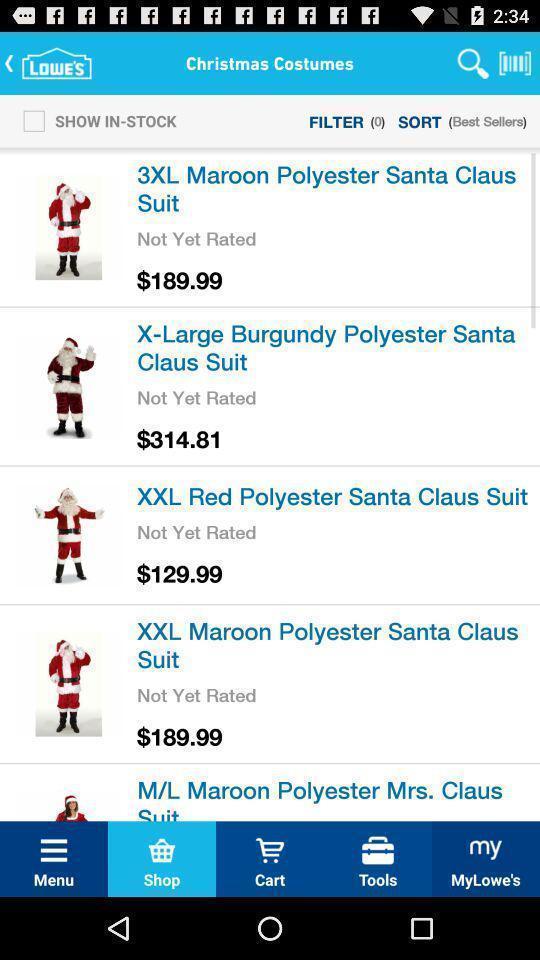Provide a detailed account of this screenshot. Screen showing list of products in e-commerce app. 